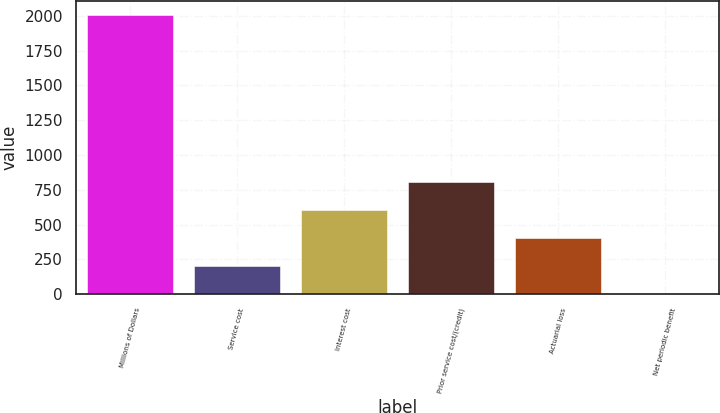Convert chart. <chart><loc_0><loc_0><loc_500><loc_500><bar_chart><fcel>Millions of Dollars<fcel>Service cost<fcel>Interest cost<fcel>Prior service cost/(credit)<fcel>Actuarial loss<fcel>Net periodic benefit<nl><fcel>2007<fcel>202.5<fcel>603.5<fcel>804<fcel>403<fcel>2<nl></chart> 